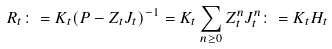Convert formula to latex. <formula><loc_0><loc_0><loc_500><loc_500>R _ { t } \colon = K _ { t } ( P - Z _ { t } J _ { t } ) ^ { - 1 } = K _ { t } \sum _ { n \geq 0 } Z _ { t } ^ { n } J _ { t } ^ { n } \colon = K _ { t } H _ { t }</formula> 